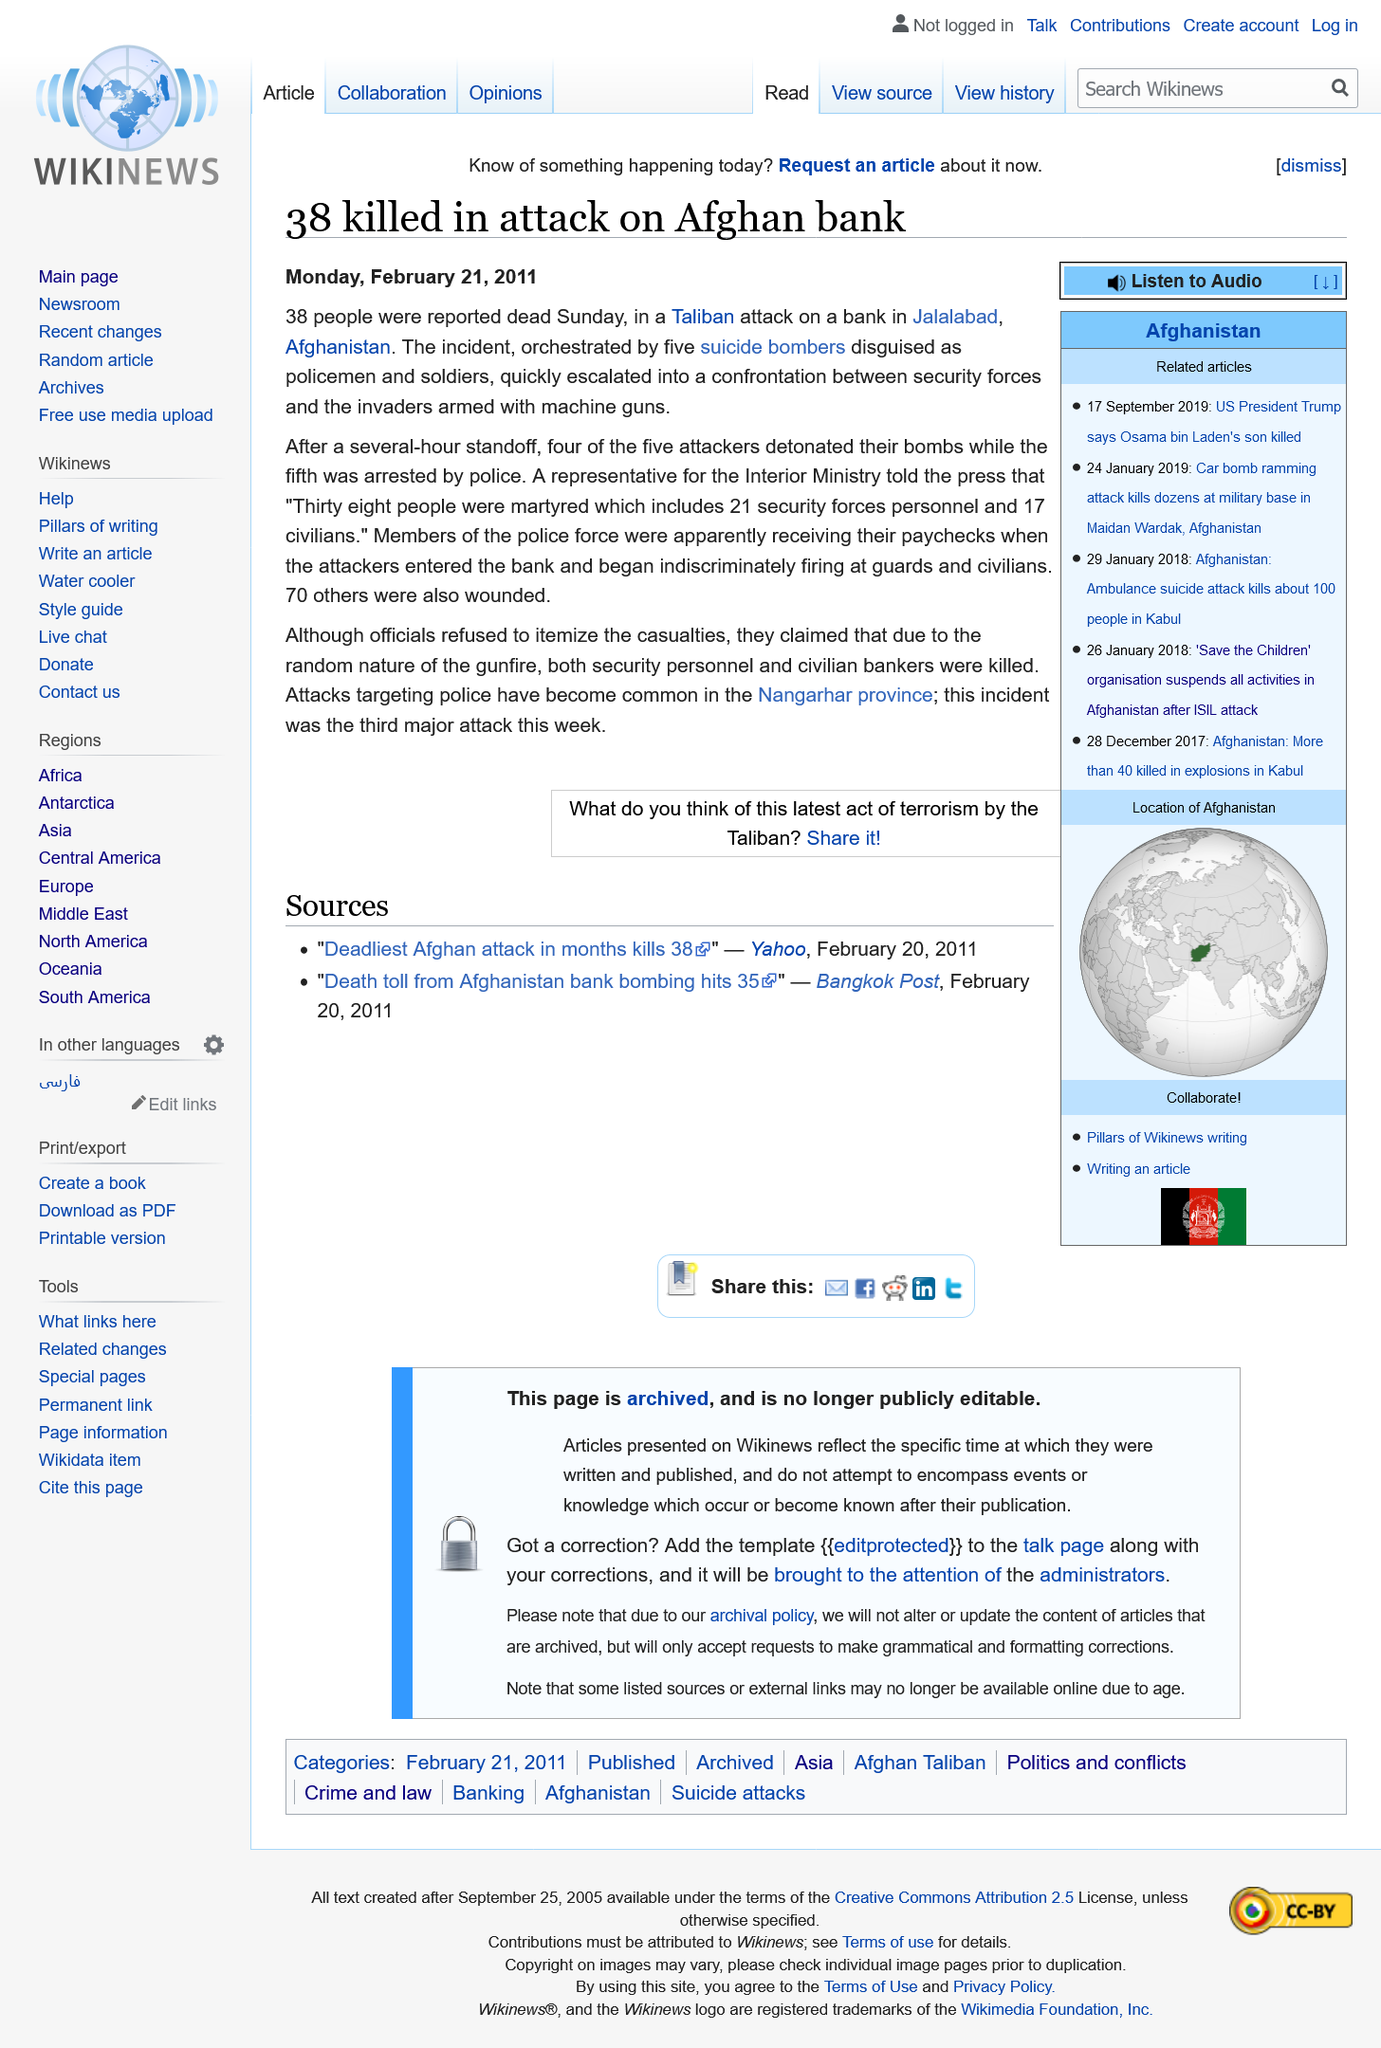List a handful of essential elements in this visual. Four of the five suicide bombers detonated their bombs. This week in Nangarhar province, there have been a total of three major attacks. On Sunday, 38 people were reported to have died. 